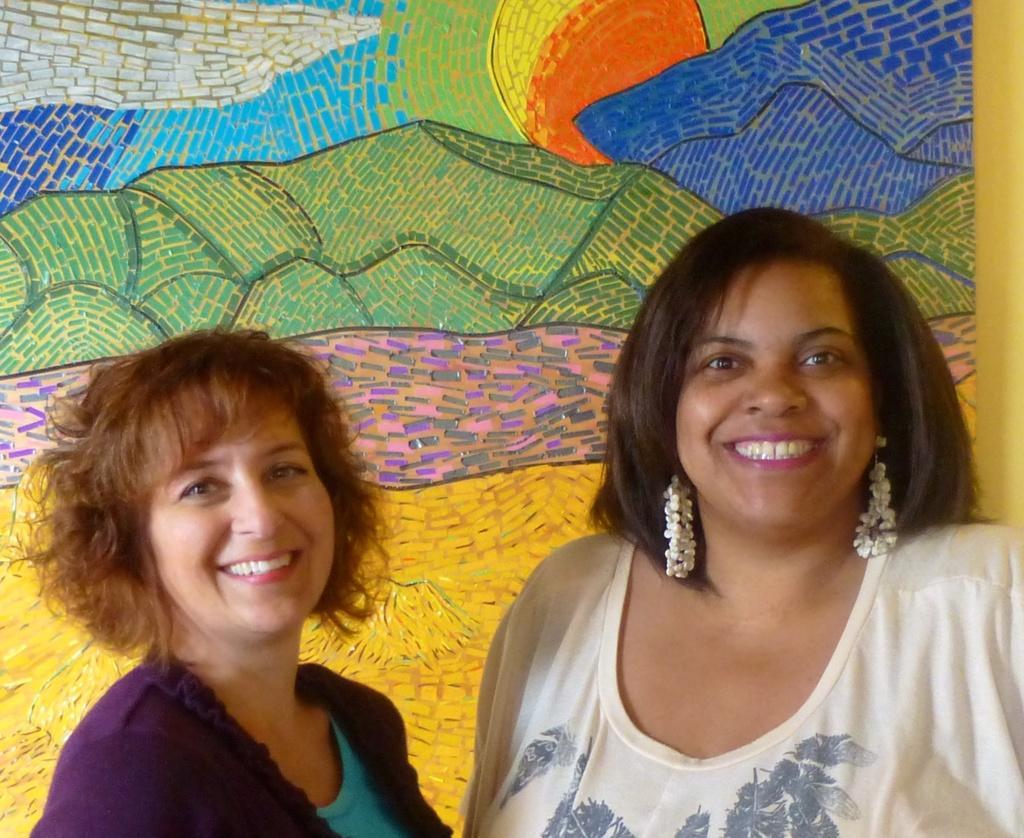How would you summarize this image in a sentence or two? This image consists of two women's and paintings on a wall. This image is taken may be during a day. 